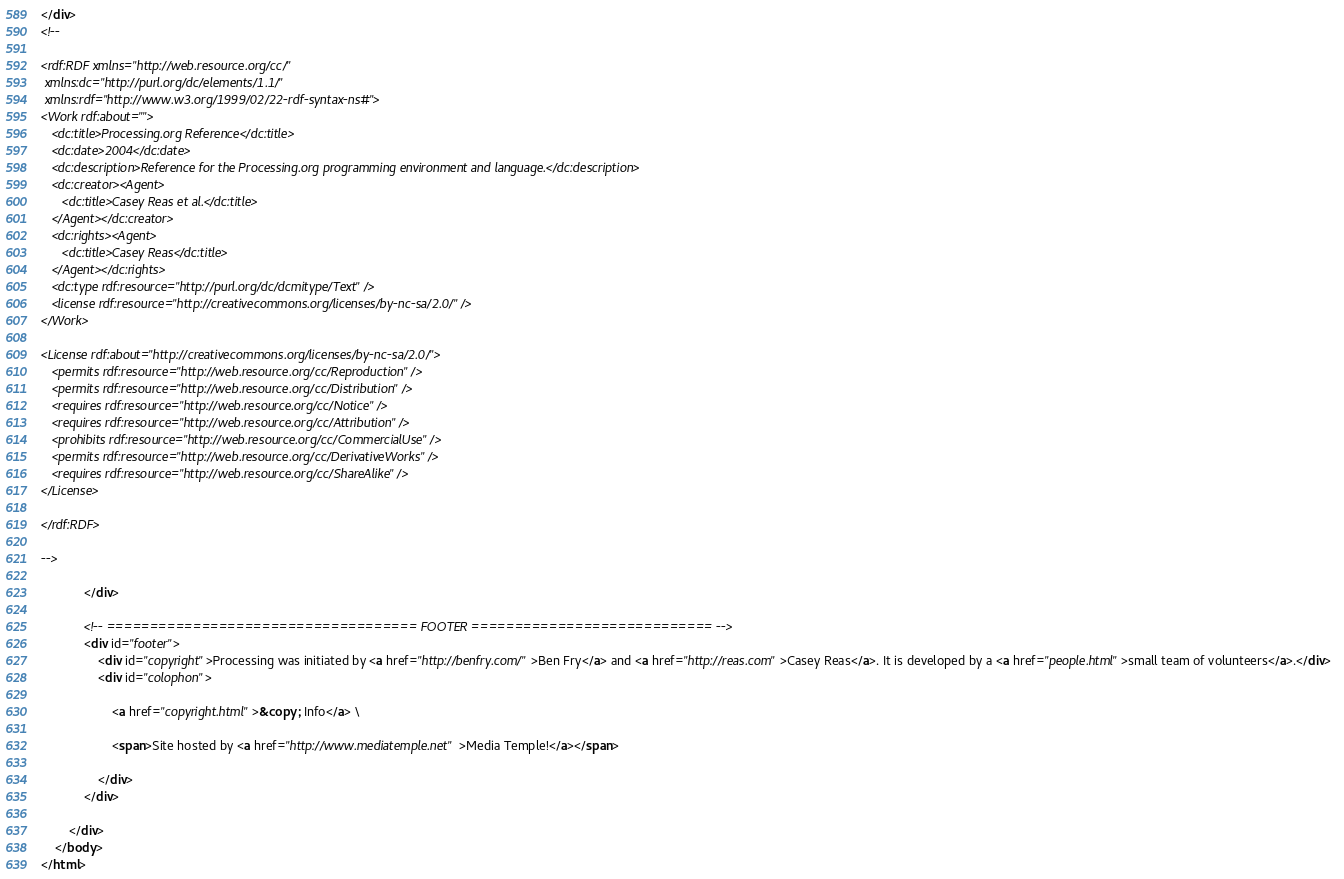<code> <loc_0><loc_0><loc_500><loc_500><_HTML_></div>
<!--

<rdf:RDF xmlns="http://web.resource.org/cc/"
 xmlns:dc="http://purl.org/dc/elements/1.1/"
 xmlns:rdf="http://www.w3.org/1999/02/22-rdf-syntax-ns#">
<Work rdf:about="">
   <dc:title>Processing.org Reference</dc:title>
   <dc:date>2004</dc:date>
   <dc:description>Reference for the Processing.org programming environment and language.</dc:description>
   <dc:creator><Agent>
      <dc:title>Casey Reas et al.</dc:title>
   </Agent></dc:creator>
   <dc:rights><Agent>
      <dc:title>Casey Reas</dc:title>
   </Agent></dc:rights>
   <dc:type rdf:resource="http://purl.org/dc/dcmitype/Text" />
   <license rdf:resource="http://creativecommons.org/licenses/by-nc-sa/2.0/" />
</Work>

<License rdf:about="http://creativecommons.org/licenses/by-nc-sa/2.0/">
   <permits rdf:resource="http://web.resource.org/cc/Reproduction" />
   <permits rdf:resource="http://web.resource.org/cc/Distribution" />
   <requires rdf:resource="http://web.resource.org/cc/Notice" />
   <requires rdf:resource="http://web.resource.org/cc/Attribution" />
   <prohibits rdf:resource="http://web.resource.org/cc/CommercialUse" />
   <permits rdf:resource="http://web.resource.org/cc/DerivativeWorks" />
   <requires rdf:resource="http://web.resource.org/cc/ShareAlike" />
</License>

</rdf:RDF>

-->
			
			</div>

			<!-- ==================================== FOOTER ============================ --> 
  			<div id="footer">
    			<div id="copyright">Processing was initiated by <a href="http://benfry.com/">Ben Fry</a> and <a href="http://reas.com">Casey Reas</a>. It is developed by a <a href="people.html">small team of volunteers</a>.</div>  
    			<div id="colophon">

                    <a href="copyright.html">&copy; Info</a> \ 

                    <span>Site hosted by <a href="http://www.mediatemple.net">Media Temple!</a></span>

                </div>
  			</div>
  			
		</div>
	</body>
</html>
</code> 